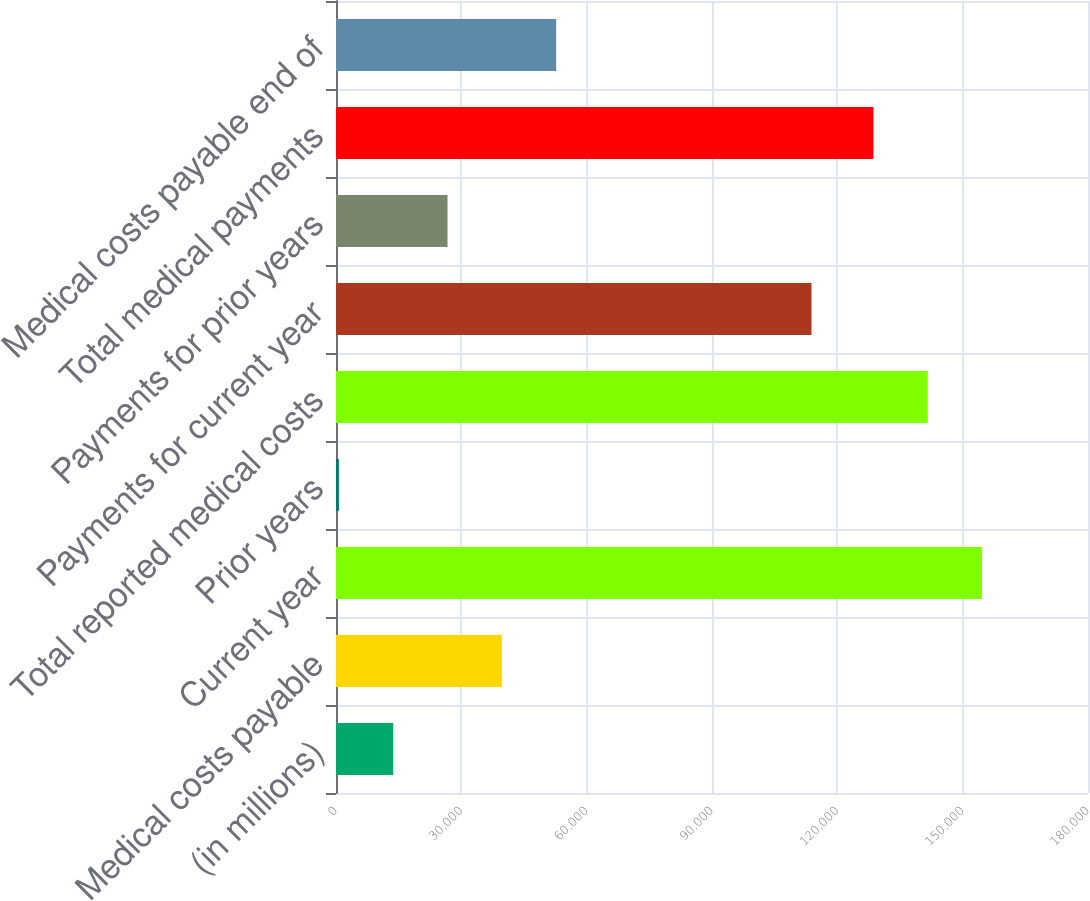Convert chart. <chart><loc_0><loc_0><loc_500><loc_500><bar_chart><fcel>(in millions)<fcel>Medical costs payable<fcel>Current year<fcel>Prior years<fcel>Total reported medical costs<fcel>Payments for current year<fcel>Payments for prior years<fcel>Total medical payments<fcel>Medical costs payable end of<nl><fcel>13693.6<fcel>39700.8<fcel>154646<fcel>690<fcel>141643<fcel>113811<fcel>26697.2<fcel>128639<fcel>52704.4<nl></chart> 